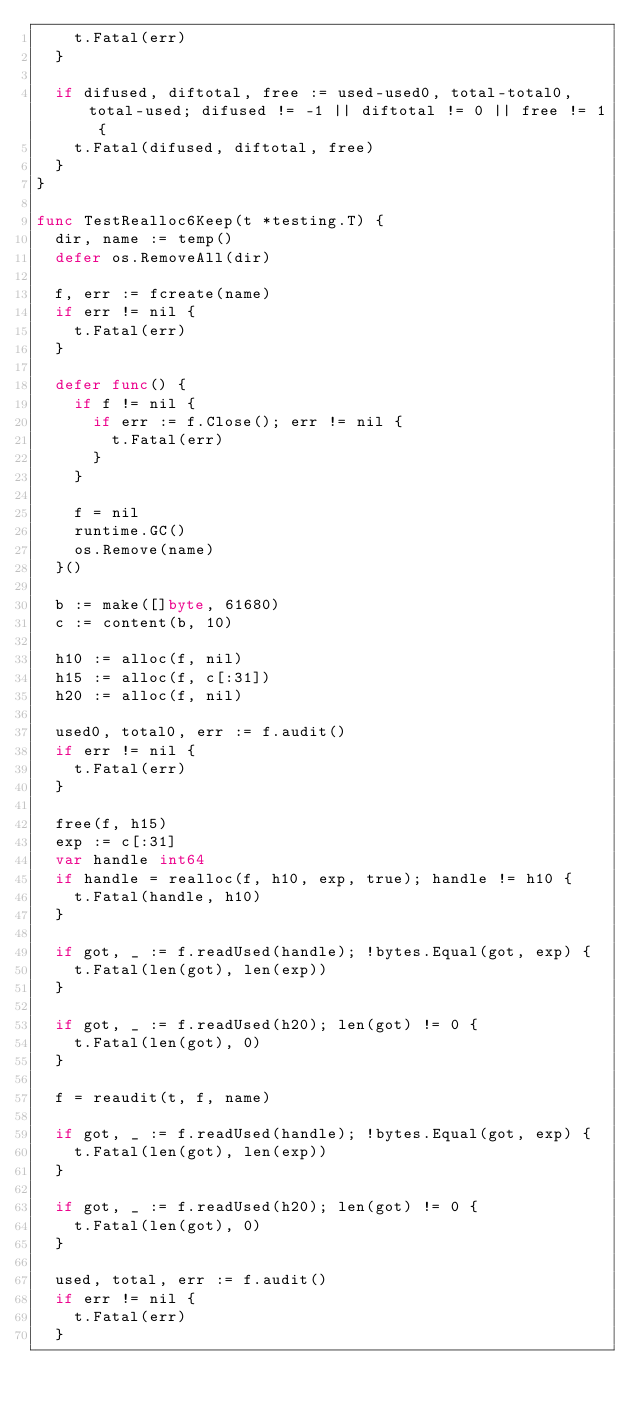<code> <loc_0><loc_0><loc_500><loc_500><_Go_>		t.Fatal(err)
	}

	if difused, diftotal, free := used-used0, total-total0, total-used; difused != -1 || diftotal != 0 || free != 1 {
		t.Fatal(difused, diftotal, free)
	}
}

func TestRealloc6Keep(t *testing.T) {
	dir, name := temp()
	defer os.RemoveAll(dir)

	f, err := fcreate(name)
	if err != nil {
		t.Fatal(err)
	}

	defer func() {
		if f != nil {
			if err := f.Close(); err != nil {
				t.Fatal(err)
			}
		}

		f = nil
		runtime.GC()
		os.Remove(name)
	}()

	b := make([]byte, 61680)
	c := content(b, 10)

	h10 := alloc(f, nil)
	h15 := alloc(f, c[:31])
	h20 := alloc(f, nil)

	used0, total0, err := f.audit()
	if err != nil {
		t.Fatal(err)
	}

	free(f, h15)
	exp := c[:31]
	var handle int64
	if handle = realloc(f, h10, exp, true); handle != h10 {
		t.Fatal(handle, h10)
	}

	if got, _ := f.readUsed(handle); !bytes.Equal(got, exp) {
		t.Fatal(len(got), len(exp))
	}

	if got, _ := f.readUsed(h20); len(got) != 0 {
		t.Fatal(len(got), 0)
	}

	f = reaudit(t, f, name)

	if got, _ := f.readUsed(handle); !bytes.Equal(got, exp) {
		t.Fatal(len(got), len(exp))
	}

	if got, _ := f.readUsed(h20); len(got) != 0 {
		t.Fatal(len(got), 0)
	}

	used, total, err := f.audit()
	if err != nil {
		t.Fatal(err)
	}
</code> 